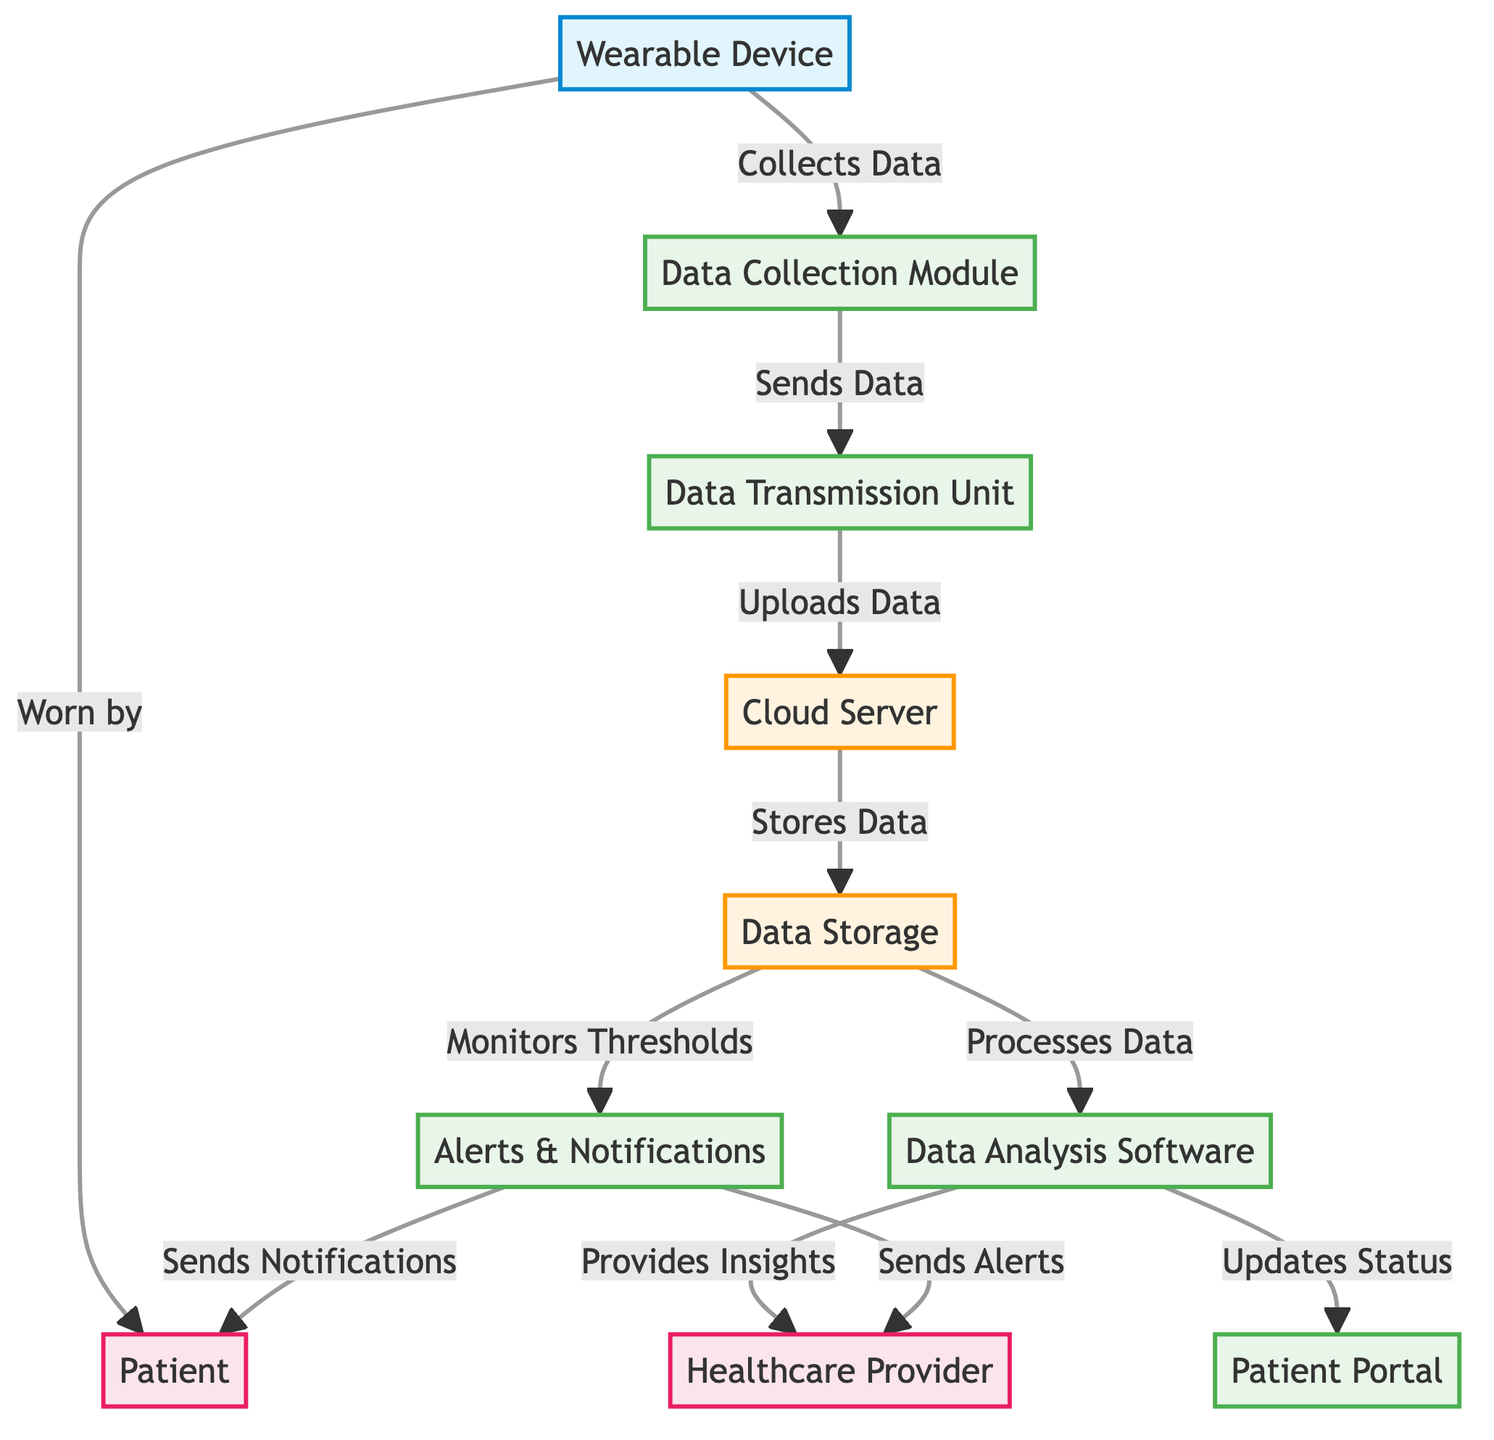What type of device is at the beginning of the flowchart? The flowchart starts with a "Wearable Device," which is indicated as the first node at the top of the diagram.
Answer: Wearable Device How many processes involved in data management are depicted in the diagram? Upon examining the diagram, there are five distinct processes: "Data Collection Module," "Data Transmission Unit," "Data Analysis Software," "Patient Portal," and "Alerts & Notifications."
Answer: Five Who is responsible for monitoring the alerts in the diagram? The “Healthcare Provider” is indicated as the recipient of the alerts and notifications, as shown by the arrows leading to this node from the "Alerts & Notifications" process.
Answer: Healthcare Provider Which module is responsible for storing data after transmission? After data transmission, the next step shown is the "Cloud Server," which is responsible for storing the uploaded data.
Answer: Cloud Server What is the primary function of the data analysis software? The "Data Analysis Software" processes data and provides insights to the healthcare provider and updates status to the patient portal, reflecting its role in interpreting collected data.
Answer: Provides Insights How does the wearable device interact with the patient? The diagram illustrates that the "Wearable Device" is worn by the "Patient," creating a direct link where data collection is initiated by the patient’s use of the device.
Answer: Worn by Which component is responsible for sending notifications to the patient? According to the flowchart, the "Alerts & Notifications" process sends notifications directly to the "Patient," indicating its role in communication with the patient.
Answer: Sends Notifications What triggers the monitoring of thresholds in the data storage? The data storage component monitors thresholds based on the data it processes, which is illustrated by the connecting line from "Data Storage" to "Alerts & Notifications."
Answer: Processes Data What is the flow of data from collection to insights? The process begins with data being collected by the "Data Collection Module," which then sends the data to the "Data Transmission Unit," then uploads it to the "Cloud Server." From there, the data is stored and processed by the "Data Analysis Software," which provides insights to the healthcare provider.
Answer: Data Collection Module, Data Transmission Unit, Cloud Server, Data Storage, Data Analysis Software 